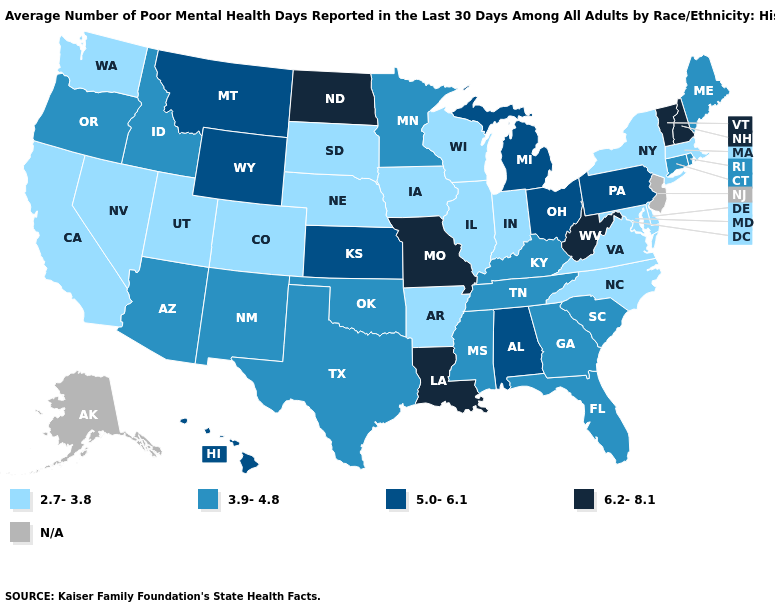Which states have the highest value in the USA?
Short answer required. Louisiana, Missouri, New Hampshire, North Dakota, Vermont, West Virginia. Among the states that border Louisiana , does Texas have the highest value?
Give a very brief answer. Yes. What is the value of Colorado?
Short answer required. 2.7-3.8. Name the states that have a value in the range N/A?
Quick response, please. Alaska, New Jersey. Name the states that have a value in the range 3.9-4.8?
Concise answer only. Arizona, Connecticut, Florida, Georgia, Idaho, Kentucky, Maine, Minnesota, Mississippi, New Mexico, Oklahoma, Oregon, Rhode Island, South Carolina, Tennessee, Texas. What is the value of Maine?
Short answer required. 3.9-4.8. Name the states that have a value in the range 2.7-3.8?
Keep it brief. Arkansas, California, Colorado, Delaware, Illinois, Indiana, Iowa, Maryland, Massachusetts, Nebraska, Nevada, New York, North Carolina, South Dakota, Utah, Virginia, Washington, Wisconsin. Name the states that have a value in the range 6.2-8.1?
Answer briefly. Louisiana, Missouri, New Hampshire, North Dakota, Vermont, West Virginia. Does Missouri have the highest value in the USA?
Keep it brief. Yes. Among the states that border Pennsylvania , does New York have the highest value?
Give a very brief answer. No. Name the states that have a value in the range 5.0-6.1?
Answer briefly. Alabama, Hawaii, Kansas, Michigan, Montana, Ohio, Pennsylvania, Wyoming. What is the lowest value in the MidWest?
Quick response, please. 2.7-3.8. Name the states that have a value in the range 2.7-3.8?
Keep it brief. Arkansas, California, Colorado, Delaware, Illinois, Indiana, Iowa, Maryland, Massachusetts, Nebraska, Nevada, New York, North Carolina, South Dakota, Utah, Virginia, Washington, Wisconsin. Is the legend a continuous bar?
Quick response, please. No. What is the value of Missouri?
Concise answer only. 6.2-8.1. 